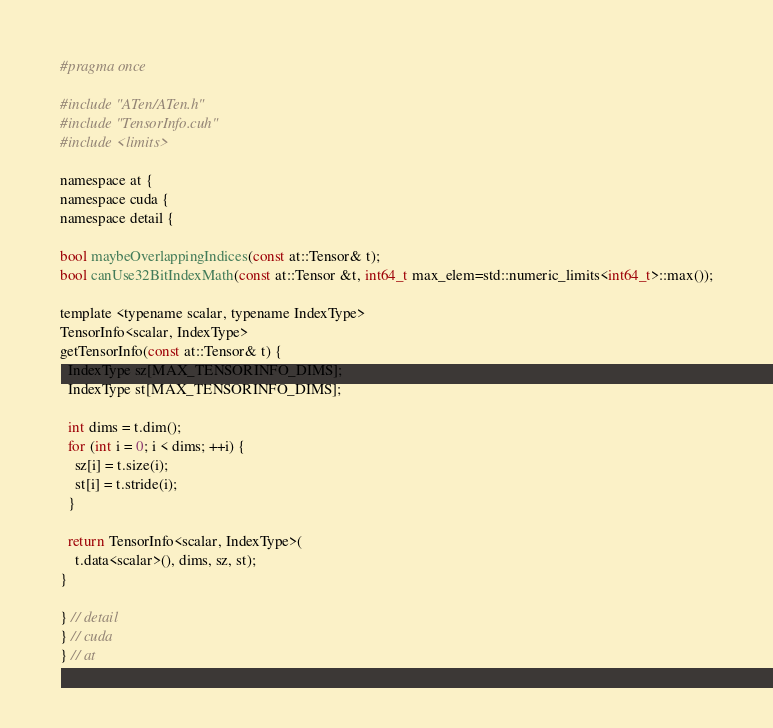Convert code to text. <code><loc_0><loc_0><loc_500><loc_500><_Cuda_>#pragma once

#include "ATen/ATen.h"
#include "TensorInfo.cuh"
#include <limits>

namespace at {
namespace cuda {
namespace detail {

bool maybeOverlappingIndices(const at::Tensor& t);
bool canUse32BitIndexMath(const at::Tensor &t, int64_t max_elem=std::numeric_limits<int64_t>::max());

template <typename scalar, typename IndexType>
TensorInfo<scalar, IndexType>
getTensorInfo(const at::Tensor& t) {
  IndexType sz[MAX_TENSORINFO_DIMS];
  IndexType st[MAX_TENSORINFO_DIMS];

  int dims = t.dim();
  for (int i = 0; i < dims; ++i) {
    sz[i] = t.size(i);
    st[i] = t.stride(i);
  }

  return TensorInfo<scalar, IndexType>(
    t.data<scalar>(), dims, sz, st);
}

} // detail
} // cuda
} // at
</code> 